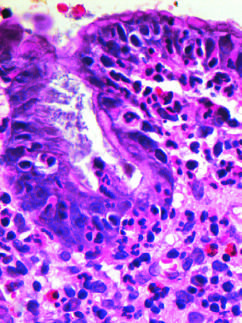re intraepithelial and lamina propria neutrophils prominent?
Answer the question using a single word or phrase. Yes 